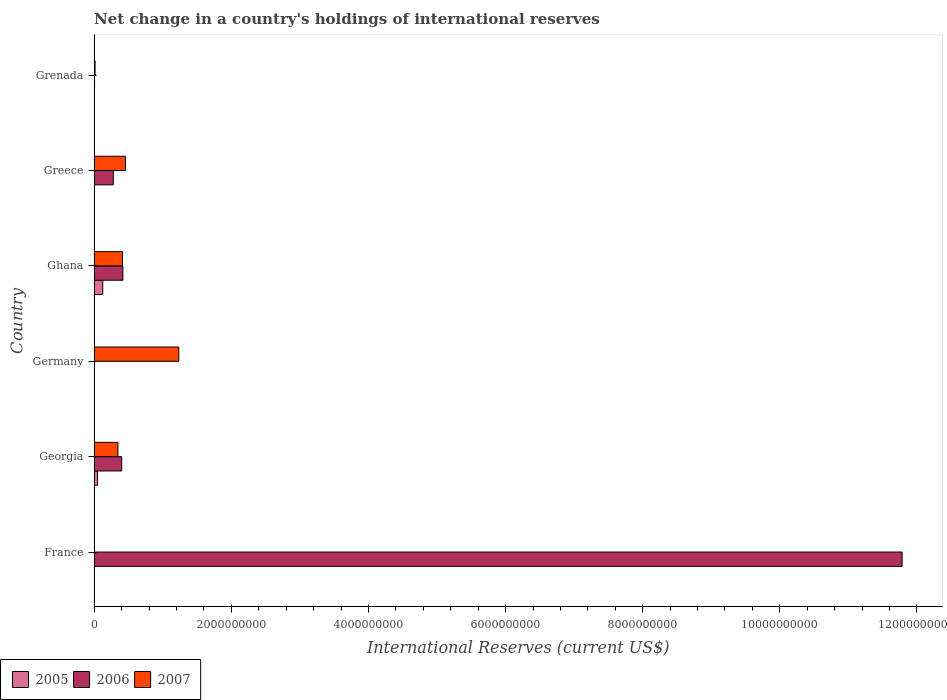Are the number of bars per tick equal to the number of legend labels?
Give a very brief answer. No. Are the number of bars on each tick of the Y-axis equal?
Your response must be concise. No. How many bars are there on the 3rd tick from the bottom?
Make the answer very short. 1. What is the label of the 4th group of bars from the top?
Provide a short and direct response. Germany. In how many cases, is the number of bars for a given country not equal to the number of legend labels?
Offer a terse response. 4. Across all countries, what is the maximum international reserves in 2005?
Your answer should be very brief. 1.25e+08. What is the total international reserves in 2006 in the graph?
Keep it short and to the point. 1.29e+1. What is the difference between the international reserves in 2006 in Greece and that in Grenada?
Provide a succinct answer. 2.73e+08. What is the difference between the international reserves in 2007 in Greece and the international reserves in 2005 in Germany?
Keep it short and to the point. 4.57e+08. What is the average international reserves in 2005 per country?
Your answer should be compact. 2.89e+07. What is the difference between the international reserves in 2006 and international reserves in 2007 in Georgia?
Provide a short and direct response. 5.57e+07. In how many countries, is the international reserves in 2006 greater than 9600000000 US$?
Provide a short and direct response. 1. What is the ratio of the international reserves in 2007 in Germany to that in Ghana?
Provide a succinct answer. 2.99. What is the difference between the highest and the second highest international reserves in 2007?
Provide a succinct answer. 7.77e+08. What is the difference between the highest and the lowest international reserves in 2007?
Keep it short and to the point. 1.23e+09. In how many countries, is the international reserves in 2007 greater than the average international reserves in 2007 taken over all countries?
Provide a short and direct response. 3. Is the sum of the international reserves in 2006 in France and Ghana greater than the maximum international reserves in 2005 across all countries?
Your answer should be compact. Yes. Is it the case that in every country, the sum of the international reserves in 2006 and international reserves in 2007 is greater than the international reserves in 2005?
Your response must be concise. Yes. How many bars are there?
Provide a short and direct response. 12. How many countries are there in the graph?
Make the answer very short. 6. Are the values on the major ticks of X-axis written in scientific E-notation?
Ensure brevity in your answer.  No. Does the graph contain any zero values?
Provide a short and direct response. Yes. How many legend labels are there?
Provide a short and direct response. 3. What is the title of the graph?
Your response must be concise. Net change in a country's holdings of international reserves. Does "1989" appear as one of the legend labels in the graph?
Keep it short and to the point. No. What is the label or title of the X-axis?
Ensure brevity in your answer.  International Reserves (current US$). What is the International Reserves (current US$) in 2006 in France?
Keep it short and to the point. 1.18e+1. What is the International Reserves (current US$) of 2007 in France?
Offer a very short reply. 0. What is the International Reserves (current US$) of 2005 in Georgia?
Provide a short and direct response. 4.88e+07. What is the International Reserves (current US$) in 2006 in Georgia?
Ensure brevity in your answer.  4.01e+08. What is the International Reserves (current US$) in 2007 in Georgia?
Provide a succinct answer. 3.45e+08. What is the International Reserves (current US$) in 2007 in Germany?
Keep it short and to the point. 1.23e+09. What is the International Reserves (current US$) in 2005 in Ghana?
Make the answer very short. 1.25e+08. What is the International Reserves (current US$) in 2006 in Ghana?
Provide a succinct answer. 4.18e+08. What is the International Reserves (current US$) in 2007 in Ghana?
Make the answer very short. 4.12e+08. What is the International Reserves (current US$) of 2005 in Greece?
Provide a short and direct response. 0. What is the International Reserves (current US$) of 2006 in Greece?
Offer a very short reply. 2.79e+08. What is the International Reserves (current US$) of 2007 in Greece?
Your answer should be very brief. 4.57e+08. What is the International Reserves (current US$) of 2005 in Grenada?
Make the answer very short. 0. What is the International Reserves (current US$) in 2006 in Grenada?
Make the answer very short. 5.10e+06. What is the International Reserves (current US$) of 2007 in Grenada?
Provide a succinct answer. 1.29e+07. Across all countries, what is the maximum International Reserves (current US$) in 2005?
Give a very brief answer. 1.25e+08. Across all countries, what is the maximum International Reserves (current US$) of 2006?
Provide a short and direct response. 1.18e+1. Across all countries, what is the maximum International Reserves (current US$) in 2007?
Make the answer very short. 1.23e+09. What is the total International Reserves (current US$) of 2005 in the graph?
Your response must be concise. 1.73e+08. What is the total International Reserves (current US$) of 2006 in the graph?
Give a very brief answer. 1.29e+1. What is the total International Reserves (current US$) of 2007 in the graph?
Provide a succinct answer. 2.46e+09. What is the difference between the International Reserves (current US$) of 2006 in France and that in Georgia?
Provide a short and direct response. 1.14e+1. What is the difference between the International Reserves (current US$) in 2006 in France and that in Ghana?
Give a very brief answer. 1.14e+1. What is the difference between the International Reserves (current US$) in 2006 in France and that in Greece?
Keep it short and to the point. 1.15e+1. What is the difference between the International Reserves (current US$) in 2006 in France and that in Grenada?
Your answer should be very brief. 1.18e+1. What is the difference between the International Reserves (current US$) of 2007 in Georgia and that in Germany?
Ensure brevity in your answer.  -8.88e+08. What is the difference between the International Reserves (current US$) in 2005 in Georgia and that in Ghana?
Provide a succinct answer. -7.59e+07. What is the difference between the International Reserves (current US$) in 2006 in Georgia and that in Ghana?
Provide a short and direct response. -1.73e+07. What is the difference between the International Reserves (current US$) in 2007 in Georgia and that in Ghana?
Your response must be concise. -6.70e+07. What is the difference between the International Reserves (current US$) of 2006 in Georgia and that in Greece?
Give a very brief answer. 1.23e+08. What is the difference between the International Reserves (current US$) of 2007 in Georgia and that in Greece?
Provide a short and direct response. -1.11e+08. What is the difference between the International Reserves (current US$) of 2006 in Georgia and that in Grenada?
Keep it short and to the point. 3.96e+08. What is the difference between the International Reserves (current US$) in 2007 in Georgia and that in Grenada?
Keep it short and to the point. 3.33e+08. What is the difference between the International Reserves (current US$) in 2007 in Germany and that in Ghana?
Keep it short and to the point. 8.21e+08. What is the difference between the International Reserves (current US$) in 2007 in Germany and that in Greece?
Your response must be concise. 7.77e+08. What is the difference between the International Reserves (current US$) of 2007 in Germany and that in Grenada?
Offer a very short reply. 1.22e+09. What is the difference between the International Reserves (current US$) in 2006 in Ghana and that in Greece?
Make the answer very short. 1.40e+08. What is the difference between the International Reserves (current US$) of 2007 in Ghana and that in Greece?
Provide a short and direct response. -4.43e+07. What is the difference between the International Reserves (current US$) of 2006 in Ghana and that in Grenada?
Keep it short and to the point. 4.13e+08. What is the difference between the International Reserves (current US$) in 2007 in Ghana and that in Grenada?
Make the answer very short. 4.00e+08. What is the difference between the International Reserves (current US$) in 2006 in Greece and that in Grenada?
Give a very brief answer. 2.73e+08. What is the difference between the International Reserves (current US$) in 2007 in Greece and that in Grenada?
Offer a terse response. 4.44e+08. What is the difference between the International Reserves (current US$) of 2006 in France and the International Reserves (current US$) of 2007 in Georgia?
Offer a very short reply. 1.14e+1. What is the difference between the International Reserves (current US$) in 2006 in France and the International Reserves (current US$) in 2007 in Germany?
Provide a short and direct response. 1.05e+1. What is the difference between the International Reserves (current US$) of 2006 in France and the International Reserves (current US$) of 2007 in Ghana?
Provide a short and direct response. 1.14e+1. What is the difference between the International Reserves (current US$) of 2006 in France and the International Reserves (current US$) of 2007 in Greece?
Offer a very short reply. 1.13e+1. What is the difference between the International Reserves (current US$) in 2006 in France and the International Reserves (current US$) in 2007 in Grenada?
Offer a terse response. 1.18e+1. What is the difference between the International Reserves (current US$) in 2005 in Georgia and the International Reserves (current US$) in 2007 in Germany?
Your answer should be compact. -1.19e+09. What is the difference between the International Reserves (current US$) in 2006 in Georgia and the International Reserves (current US$) in 2007 in Germany?
Your response must be concise. -8.33e+08. What is the difference between the International Reserves (current US$) in 2005 in Georgia and the International Reserves (current US$) in 2006 in Ghana?
Offer a terse response. -3.70e+08. What is the difference between the International Reserves (current US$) of 2005 in Georgia and the International Reserves (current US$) of 2007 in Ghana?
Your answer should be compact. -3.64e+08. What is the difference between the International Reserves (current US$) in 2006 in Georgia and the International Reserves (current US$) in 2007 in Ghana?
Provide a succinct answer. -1.14e+07. What is the difference between the International Reserves (current US$) of 2005 in Georgia and the International Reserves (current US$) of 2006 in Greece?
Make the answer very short. -2.30e+08. What is the difference between the International Reserves (current US$) of 2005 in Georgia and the International Reserves (current US$) of 2007 in Greece?
Keep it short and to the point. -4.08e+08. What is the difference between the International Reserves (current US$) of 2006 in Georgia and the International Reserves (current US$) of 2007 in Greece?
Give a very brief answer. -5.56e+07. What is the difference between the International Reserves (current US$) of 2005 in Georgia and the International Reserves (current US$) of 2006 in Grenada?
Provide a short and direct response. 4.37e+07. What is the difference between the International Reserves (current US$) in 2005 in Georgia and the International Reserves (current US$) in 2007 in Grenada?
Your response must be concise. 3.59e+07. What is the difference between the International Reserves (current US$) of 2006 in Georgia and the International Reserves (current US$) of 2007 in Grenada?
Your answer should be very brief. 3.88e+08. What is the difference between the International Reserves (current US$) in 2005 in Ghana and the International Reserves (current US$) in 2006 in Greece?
Provide a succinct answer. -1.54e+08. What is the difference between the International Reserves (current US$) in 2005 in Ghana and the International Reserves (current US$) in 2007 in Greece?
Give a very brief answer. -3.32e+08. What is the difference between the International Reserves (current US$) of 2006 in Ghana and the International Reserves (current US$) of 2007 in Greece?
Offer a terse response. -3.83e+07. What is the difference between the International Reserves (current US$) of 2005 in Ghana and the International Reserves (current US$) of 2006 in Grenada?
Provide a short and direct response. 1.20e+08. What is the difference between the International Reserves (current US$) in 2005 in Ghana and the International Reserves (current US$) in 2007 in Grenada?
Offer a very short reply. 1.12e+08. What is the difference between the International Reserves (current US$) of 2006 in Ghana and the International Reserves (current US$) of 2007 in Grenada?
Keep it short and to the point. 4.06e+08. What is the difference between the International Reserves (current US$) of 2006 in Greece and the International Reserves (current US$) of 2007 in Grenada?
Provide a succinct answer. 2.66e+08. What is the average International Reserves (current US$) of 2005 per country?
Offer a terse response. 2.89e+07. What is the average International Reserves (current US$) in 2006 per country?
Ensure brevity in your answer.  2.15e+09. What is the average International Reserves (current US$) in 2007 per country?
Offer a terse response. 4.10e+08. What is the difference between the International Reserves (current US$) of 2005 and International Reserves (current US$) of 2006 in Georgia?
Offer a very short reply. -3.52e+08. What is the difference between the International Reserves (current US$) of 2005 and International Reserves (current US$) of 2007 in Georgia?
Keep it short and to the point. -2.97e+08. What is the difference between the International Reserves (current US$) in 2006 and International Reserves (current US$) in 2007 in Georgia?
Ensure brevity in your answer.  5.57e+07. What is the difference between the International Reserves (current US$) of 2005 and International Reserves (current US$) of 2006 in Ghana?
Give a very brief answer. -2.94e+08. What is the difference between the International Reserves (current US$) of 2005 and International Reserves (current US$) of 2007 in Ghana?
Your response must be concise. -2.88e+08. What is the difference between the International Reserves (current US$) in 2006 and International Reserves (current US$) in 2007 in Ghana?
Provide a succinct answer. 5.98e+06. What is the difference between the International Reserves (current US$) in 2006 and International Reserves (current US$) in 2007 in Greece?
Offer a very short reply. -1.78e+08. What is the difference between the International Reserves (current US$) in 2006 and International Reserves (current US$) in 2007 in Grenada?
Make the answer very short. -7.83e+06. What is the ratio of the International Reserves (current US$) of 2006 in France to that in Georgia?
Provide a succinct answer. 29.38. What is the ratio of the International Reserves (current US$) of 2006 in France to that in Ghana?
Ensure brevity in your answer.  28.16. What is the ratio of the International Reserves (current US$) in 2006 in France to that in Greece?
Offer a terse response. 42.31. What is the ratio of the International Reserves (current US$) of 2006 in France to that in Grenada?
Offer a terse response. 2312.62. What is the ratio of the International Reserves (current US$) in 2007 in Georgia to that in Germany?
Give a very brief answer. 0.28. What is the ratio of the International Reserves (current US$) of 2005 in Georgia to that in Ghana?
Your answer should be very brief. 0.39. What is the ratio of the International Reserves (current US$) in 2006 in Georgia to that in Ghana?
Offer a terse response. 0.96. What is the ratio of the International Reserves (current US$) in 2007 in Georgia to that in Ghana?
Offer a terse response. 0.84. What is the ratio of the International Reserves (current US$) in 2006 in Georgia to that in Greece?
Your response must be concise. 1.44. What is the ratio of the International Reserves (current US$) of 2007 in Georgia to that in Greece?
Your answer should be compact. 0.76. What is the ratio of the International Reserves (current US$) of 2006 in Georgia to that in Grenada?
Offer a very short reply. 78.72. What is the ratio of the International Reserves (current US$) in 2007 in Georgia to that in Grenada?
Ensure brevity in your answer.  26.72. What is the ratio of the International Reserves (current US$) in 2007 in Germany to that in Ghana?
Provide a succinct answer. 2.99. What is the ratio of the International Reserves (current US$) in 2007 in Germany to that in Greece?
Give a very brief answer. 2.7. What is the ratio of the International Reserves (current US$) of 2007 in Germany to that in Grenada?
Make the answer very short. 95.45. What is the ratio of the International Reserves (current US$) of 2006 in Ghana to that in Greece?
Your response must be concise. 1.5. What is the ratio of the International Reserves (current US$) in 2007 in Ghana to that in Greece?
Offer a very short reply. 0.9. What is the ratio of the International Reserves (current US$) of 2006 in Ghana to that in Grenada?
Your answer should be compact. 82.13. What is the ratio of the International Reserves (current US$) of 2007 in Ghana to that in Grenada?
Ensure brevity in your answer.  31.91. What is the ratio of the International Reserves (current US$) of 2006 in Greece to that in Grenada?
Your answer should be compact. 54.66. What is the ratio of the International Reserves (current US$) in 2007 in Greece to that in Grenada?
Your answer should be compact. 35.33. What is the difference between the highest and the second highest International Reserves (current US$) in 2006?
Provide a succinct answer. 1.14e+1. What is the difference between the highest and the second highest International Reserves (current US$) in 2007?
Ensure brevity in your answer.  7.77e+08. What is the difference between the highest and the lowest International Reserves (current US$) of 2005?
Your response must be concise. 1.25e+08. What is the difference between the highest and the lowest International Reserves (current US$) of 2006?
Give a very brief answer. 1.18e+1. What is the difference between the highest and the lowest International Reserves (current US$) in 2007?
Keep it short and to the point. 1.23e+09. 